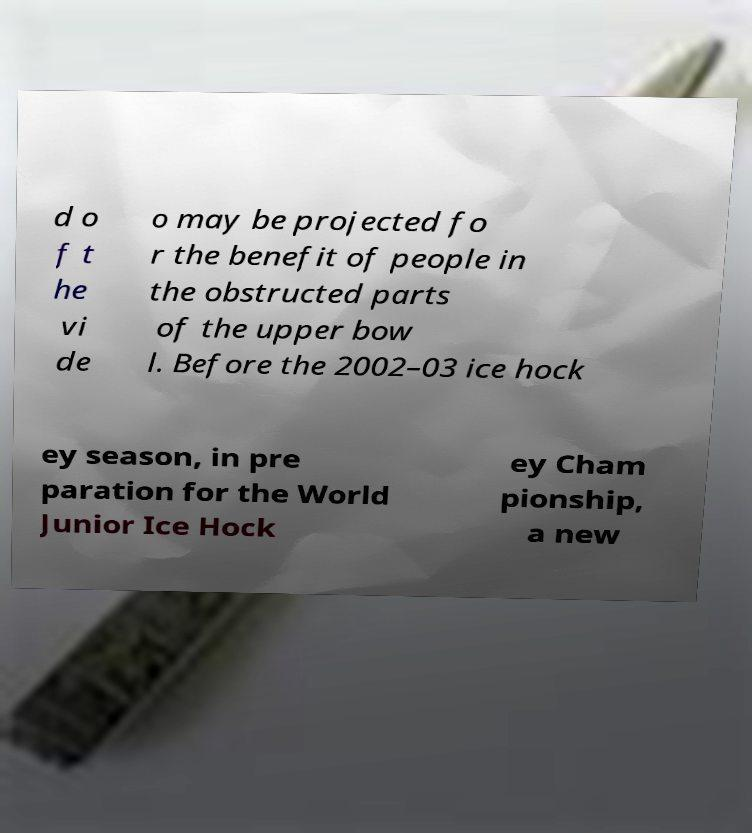Could you extract and type out the text from this image? d o f t he vi de o may be projected fo r the benefit of people in the obstructed parts of the upper bow l. Before the 2002–03 ice hock ey season, in pre paration for the World Junior Ice Hock ey Cham pionship, a new 